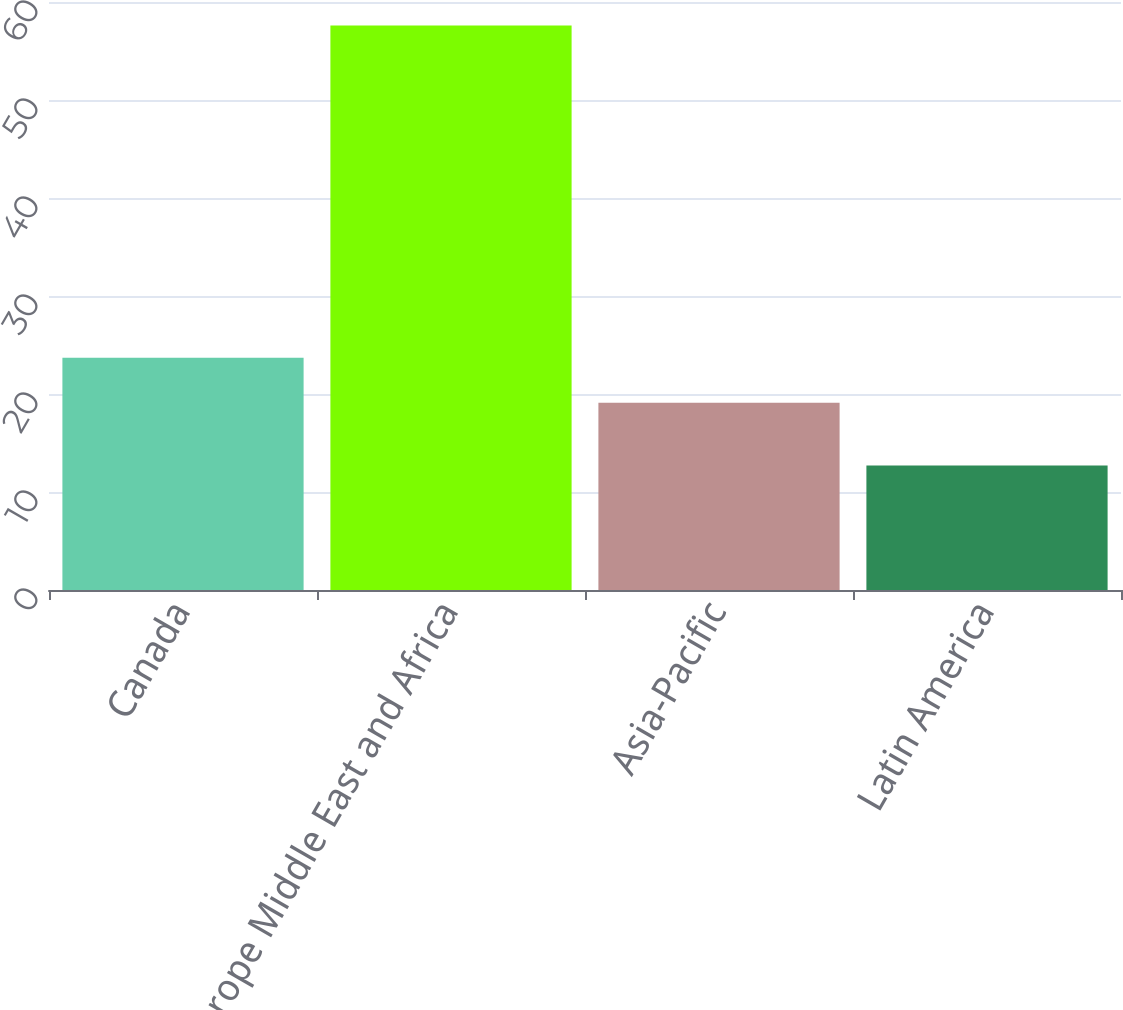<chart> <loc_0><loc_0><loc_500><loc_500><bar_chart><fcel>Canada<fcel>Europe Middle East and Africa<fcel>Asia-Pacific<fcel>Latin America<nl><fcel>23.7<fcel>57.6<fcel>19.1<fcel>12.7<nl></chart> 